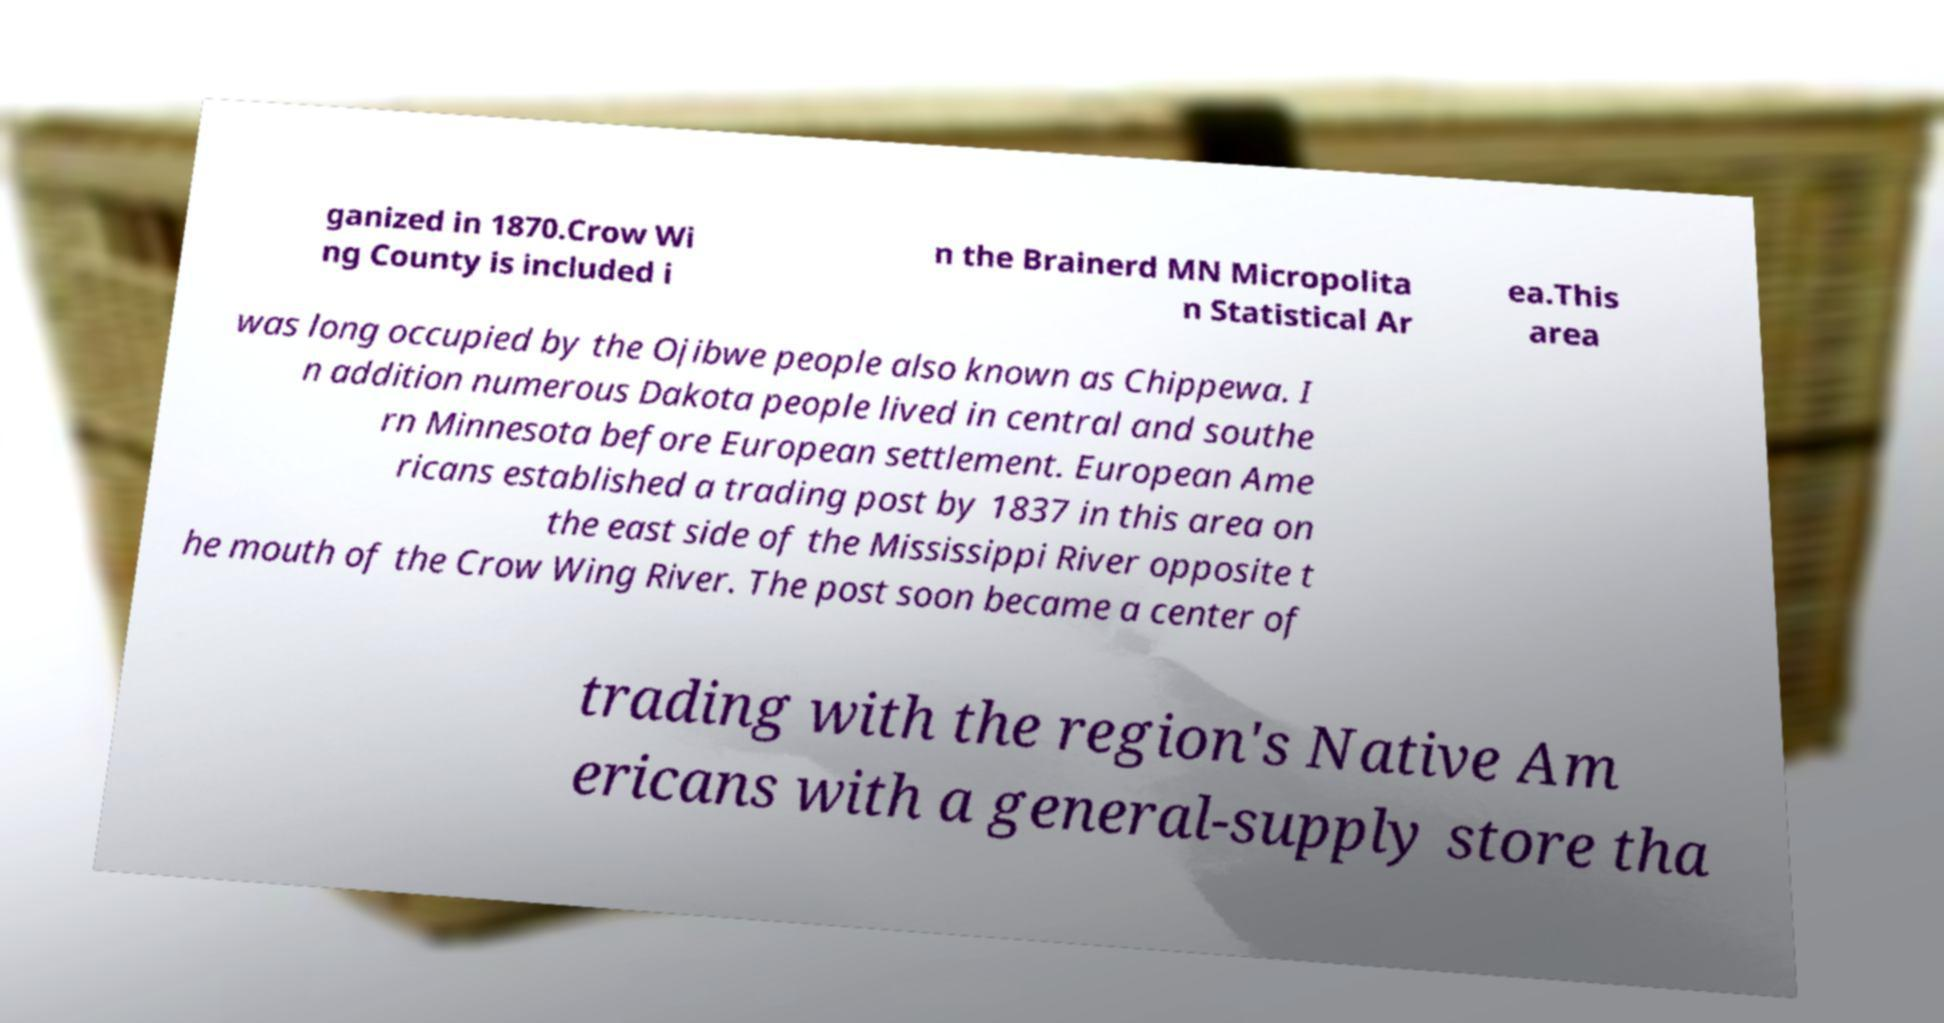Can you accurately transcribe the text from the provided image for me? ganized in 1870.Crow Wi ng County is included i n the Brainerd MN Micropolita n Statistical Ar ea.This area was long occupied by the Ojibwe people also known as Chippewa. I n addition numerous Dakota people lived in central and southe rn Minnesota before European settlement. European Ame ricans established a trading post by 1837 in this area on the east side of the Mississippi River opposite t he mouth of the Crow Wing River. The post soon became a center of trading with the region's Native Am ericans with a general-supply store tha 